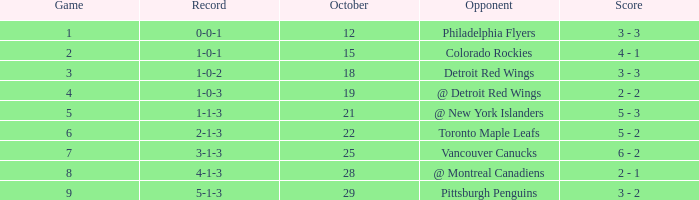Name the least game for october 21 5.0. 